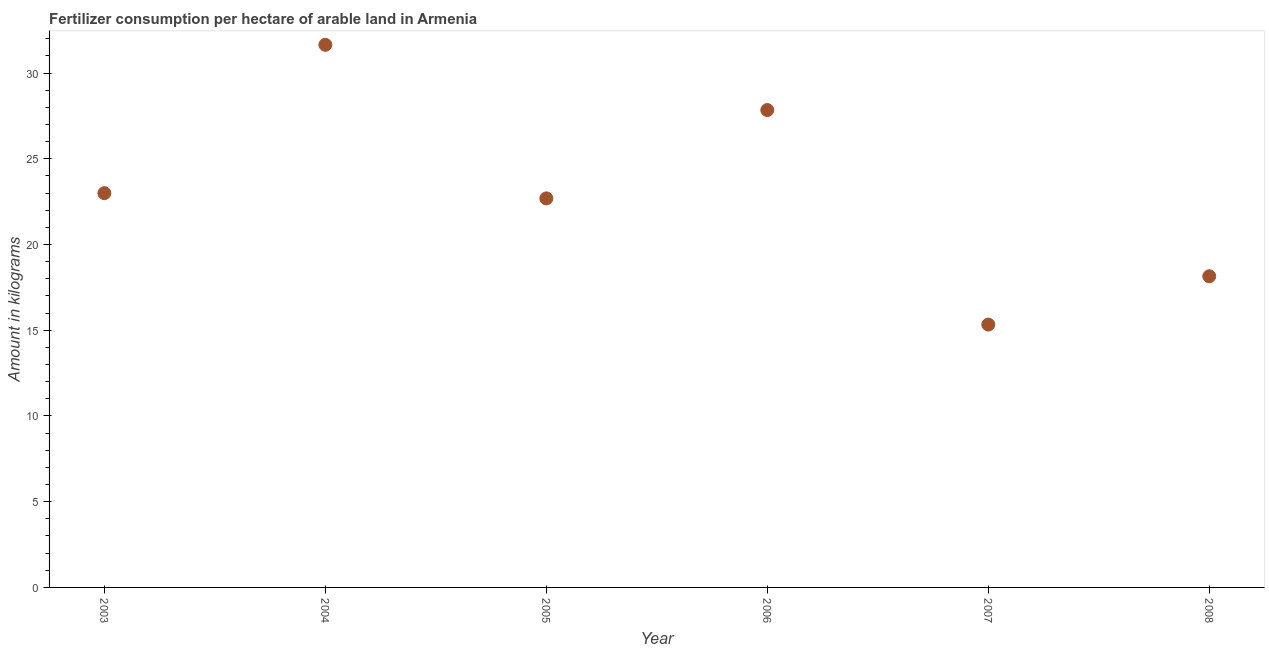What is the amount of fertilizer consumption in 2006?
Offer a very short reply. 27.84. Across all years, what is the maximum amount of fertilizer consumption?
Provide a short and direct response. 31.65. Across all years, what is the minimum amount of fertilizer consumption?
Offer a very short reply. 15.33. What is the sum of the amount of fertilizer consumption?
Make the answer very short. 138.67. What is the difference between the amount of fertilizer consumption in 2005 and 2007?
Offer a very short reply. 7.36. What is the average amount of fertilizer consumption per year?
Give a very brief answer. 23.11. What is the median amount of fertilizer consumption?
Offer a very short reply. 22.85. What is the ratio of the amount of fertilizer consumption in 2003 to that in 2005?
Provide a succinct answer. 1.01. Is the amount of fertilizer consumption in 2004 less than that in 2007?
Offer a very short reply. No. Is the difference between the amount of fertilizer consumption in 2004 and 2007 greater than the difference between any two years?
Your answer should be very brief. Yes. What is the difference between the highest and the second highest amount of fertilizer consumption?
Offer a terse response. 3.81. What is the difference between the highest and the lowest amount of fertilizer consumption?
Provide a succinct answer. 16.32. In how many years, is the amount of fertilizer consumption greater than the average amount of fertilizer consumption taken over all years?
Offer a very short reply. 2. How many years are there in the graph?
Offer a terse response. 6. Are the values on the major ticks of Y-axis written in scientific E-notation?
Ensure brevity in your answer.  No. Does the graph contain any zero values?
Offer a very short reply. No. What is the title of the graph?
Offer a terse response. Fertilizer consumption per hectare of arable land in Armenia . What is the label or title of the X-axis?
Provide a succinct answer. Year. What is the label or title of the Y-axis?
Make the answer very short. Amount in kilograms. What is the Amount in kilograms in 2003?
Offer a very short reply. 23. What is the Amount in kilograms in 2004?
Ensure brevity in your answer.  31.65. What is the Amount in kilograms in 2005?
Give a very brief answer. 22.69. What is the Amount in kilograms in 2006?
Provide a short and direct response. 27.84. What is the Amount in kilograms in 2007?
Provide a short and direct response. 15.33. What is the Amount in kilograms in 2008?
Your answer should be very brief. 18.15. What is the difference between the Amount in kilograms in 2003 and 2004?
Offer a very short reply. -8.65. What is the difference between the Amount in kilograms in 2003 and 2005?
Make the answer very short. 0.31. What is the difference between the Amount in kilograms in 2003 and 2006?
Give a very brief answer. -4.85. What is the difference between the Amount in kilograms in 2003 and 2007?
Ensure brevity in your answer.  7.66. What is the difference between the Amount in kilograms in 2003 and 2008?
Make the answer very short. 4.85. What is the difference between the Amount in kilograms in 2004 and 2005?
Your response must be concise. 8.96. What is the difference between the Amount in kilograms in 2004 and 2006?
Keep it short and to the point. 3.81. What is the difference between the Amount in kilograms in 2004 and 2007?
Your answer should be compact. 16.32. What is the difference between the Amount in kilograms in 2004 and 2008?
Your answer should be very brief. 13.5. What is the difference between the Amount in kilograms in 2005 and 2006?
Offer a very short reply. -5.15. What is the difference between the Amount in kilograms in 2005 and 2007?
Keep it short and to the point. 7.36. What is the difference between the Amount in kilograms in 2005 and 2008?
Provide a succinct answer. 4.54. What is the difference between the Amount in kilograms in 2006 and 2007?
Keep it short and to the point. 12.51. What is the difference between the Amount in kilograms in 2006 and 2008?
Offer a very short reply. 9.69. What is the difference between the Amount in kilograms in 2007 and 2008?
Keep it short and to the point. -2.82. What is the ratio of the Amount in kilograms in 2003 to that in 2004?
Keep it short and to the point. 0.73. What is the ratio of the Amount in kilograms in 2003 to that in 2006?
Your answer should be compact. 0.83. What is the ratio of the Amount in kilograms in 2003 to that in 2008?
Provide a short and direct response. 1.27. What is the ratio of the Amount in kilograms in 2004 to that in 2005?
Keep it short and to the point. 1.4. What is the ratio of the Amount in kilograms in 2004 to that in 2006?
Provide a succinct answer. 1.14. What is the ratio of the Amount in kilograms in 2004 to that in 2007?
Provide a succinct answer. 2.06. What is the ratio of the Amount in kilograms in 2004 to that in 2008?
Give a very brief answer. 1.74. What is the ratio of the Amount in kilograms in 2005 to that in 2006?
Provide a succinct answer. 0.81. What is the ratio of the Amount in kilograms in 2005 to that in 2007?
Keep it short and to the point. 1.48. What is the ratio of the Amount in kilograms in 2006 to that in 2007?
Give a very brief answer. 1.82. What is the ratio of the Amount in kilograms in 2006 to that in 2008?
Provide a short and direct response. 1.53. What is the ratio of the Amount in kilograms in 2007 to that in 2008?
Your response must be concise. 0.84. 